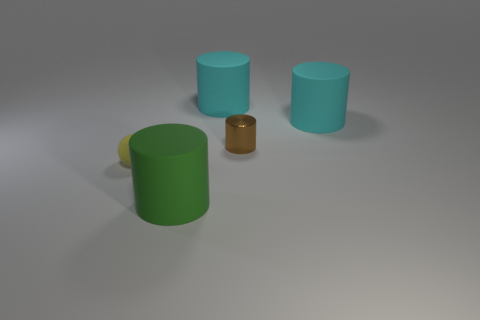Add 1 large matte cylinders. How many objects exist? 6 Subtract all spheres. How many objects are left? 4 Subtract all gray shiny things. Subtract all cyan rubber cylinders. How many objects are left? 3 Add 5 tiny yellow balls. How many tiny yellow balls are left? 6 Add 5 small cyan shiny blocks. How many small cyan shiny blocks exist? 5 Subtract 0 gray balls. How many objects are left? 5 